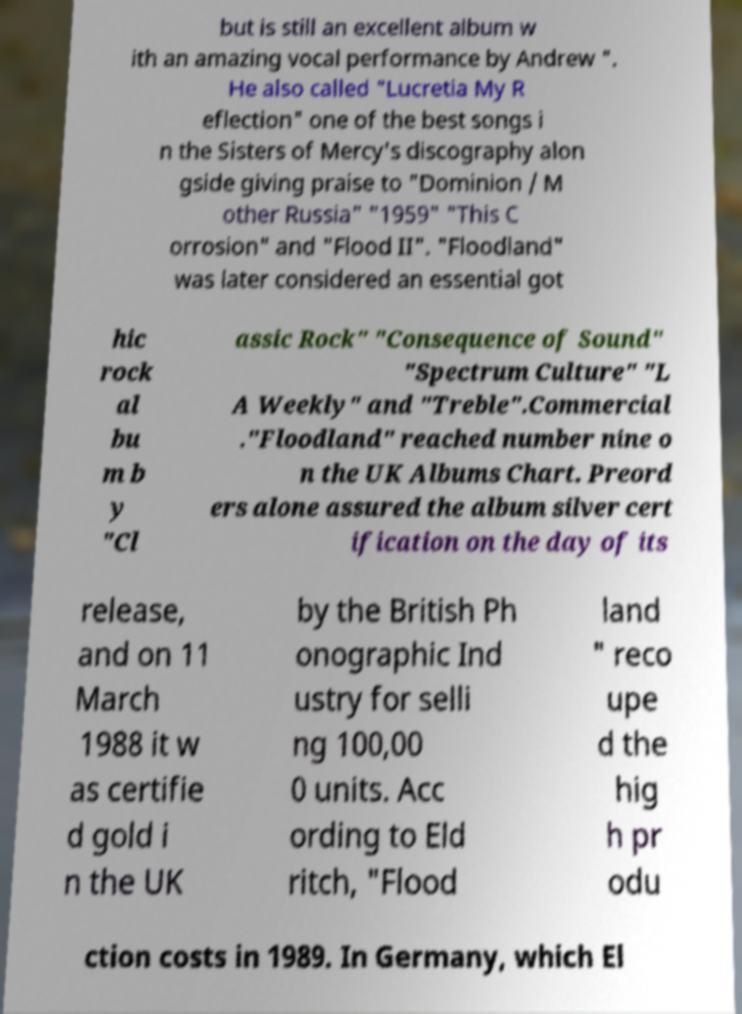What messages or text are displayed in this image? I need them in a readable, typed format. but is still an excellent album w ith an amazing vocal performance by Andrew ". He also called "Lucretia My R eflection" one of the best songs i n the Sisters of Mercy's discography alon gside giving praise to "Dominion / M other Russia" "1959" "This C orrosion" and "Flood II". "Floodland" was later considered an essential got hic rock al bu m b y "Cl assic Rock" "Consequence of Sound" "Spectrum Culture" "L A Weekly" and "Treble".Commercial ."Floodland" reached number nine o n the UK Albums Chart. Preord ers alone assured the album silver cert ification on the day of its release, and on 11 March 1988 it w as certifie d gold i n the UK by the British Ph onographic Ind ustry for selli ng 100,00 0 units. Acc ording to Eld ritch, "Flood land " reco upe d the hig h pr odu ction costs in 1989. In Germany, which El 